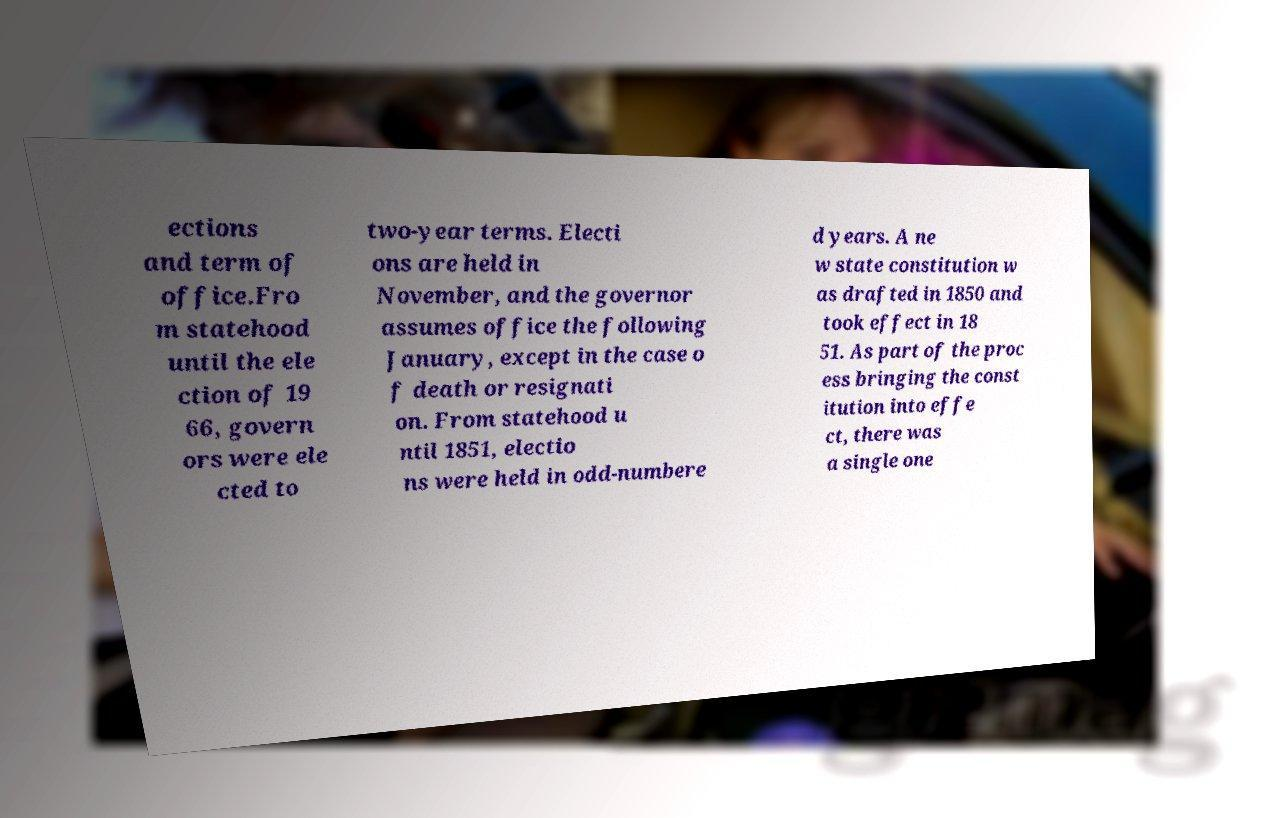For documentation purposes, I need the text within this image transcribed. Could you provide that? ections and term of office.Fro m statehood until the ele ction of 19 66, govern ors were ele cted to two-year terms. Electi ons are held in November, and the governor assumes office the following January, except in the case o f death or resignati on. From statehood u ntil 1851, electio ns were held in odd-numbere d years. A ne w state constitution w as drafted in 1850 and took effect in 18 51. As part of the proc ess bringing the const itution into effe ct, there was a single one 